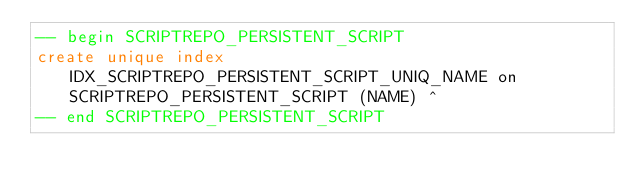Convert code to text. <code><loc_0><loc_0><loc_500><loc_500><_SQL_>-- begin SCRIPTREPO_PERSISTENT_SCRIPT
create unique index IDX_SCRIPTREPO_PERSISTENT_SCRIPT_UNIQ_NAME on SCRIPTREPO_PERSISTENT_SCRIPT (NAME) ^
-- end SCRIPTREPO_PERSISTENT_SCRIPT
</code> 